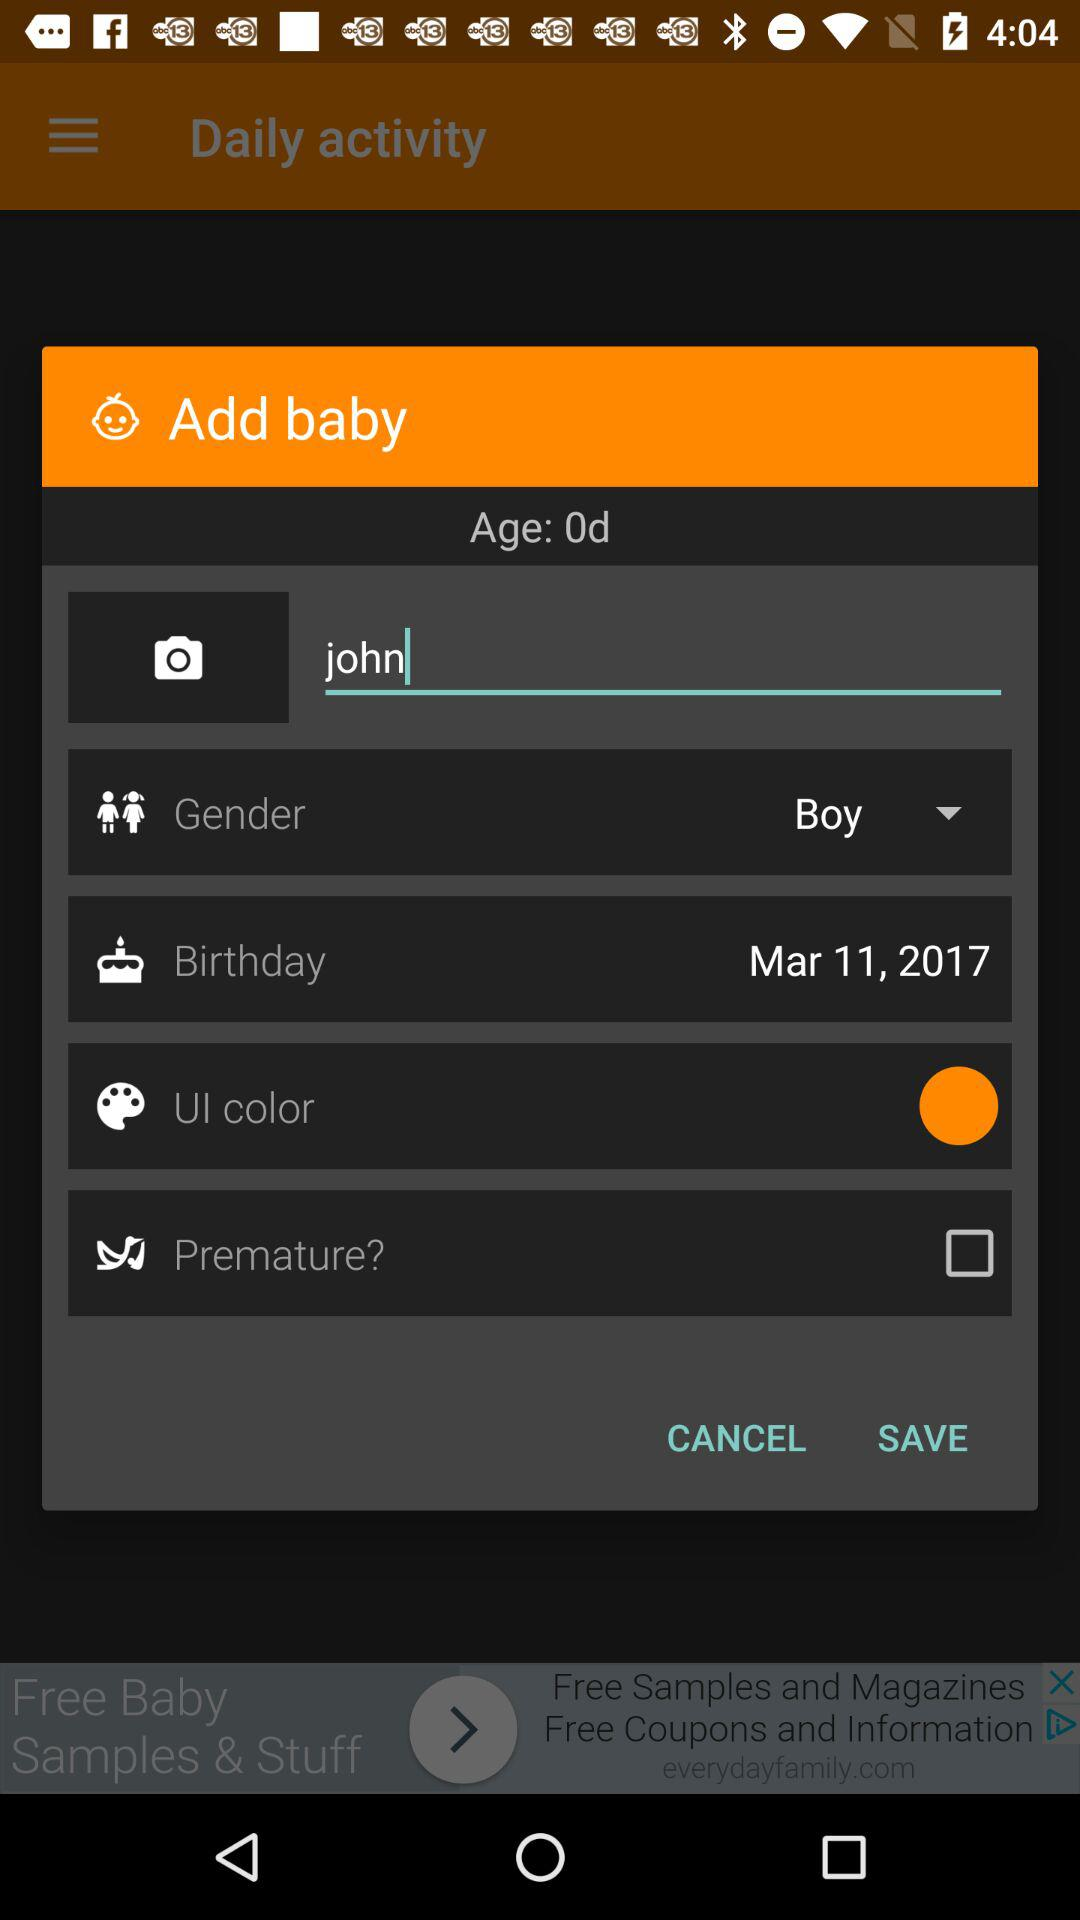What is the status of the "Premature?"? The status is "off". 